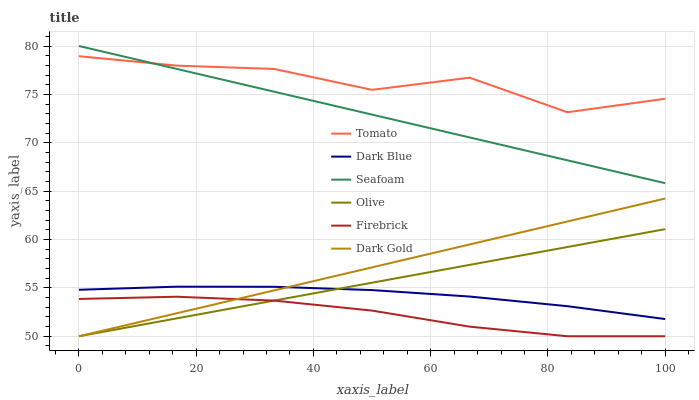Does Dark Gold have the minimum area under the curve?
Answer yes or no. No. Does Dark Gold have the maximum area under the curve?
Answer yes or no. No. Is Firebrick the smoothest?
Answer yes or no. No. Is Firebrick the roughest?
Answer yes or no. No. Does Seafoam have the lowest value?
Answer yes or no. No. Does Dark Gold have the highest value?
Answer yes or no. No. Is Dark Blue less than Seafoam?
Answer yes or no. Yes. Is Seafoam greater than Olive?
Answer yes or no. Yes. Does Dark Blue intersect Seafoam?
Answer yes or no. No. 